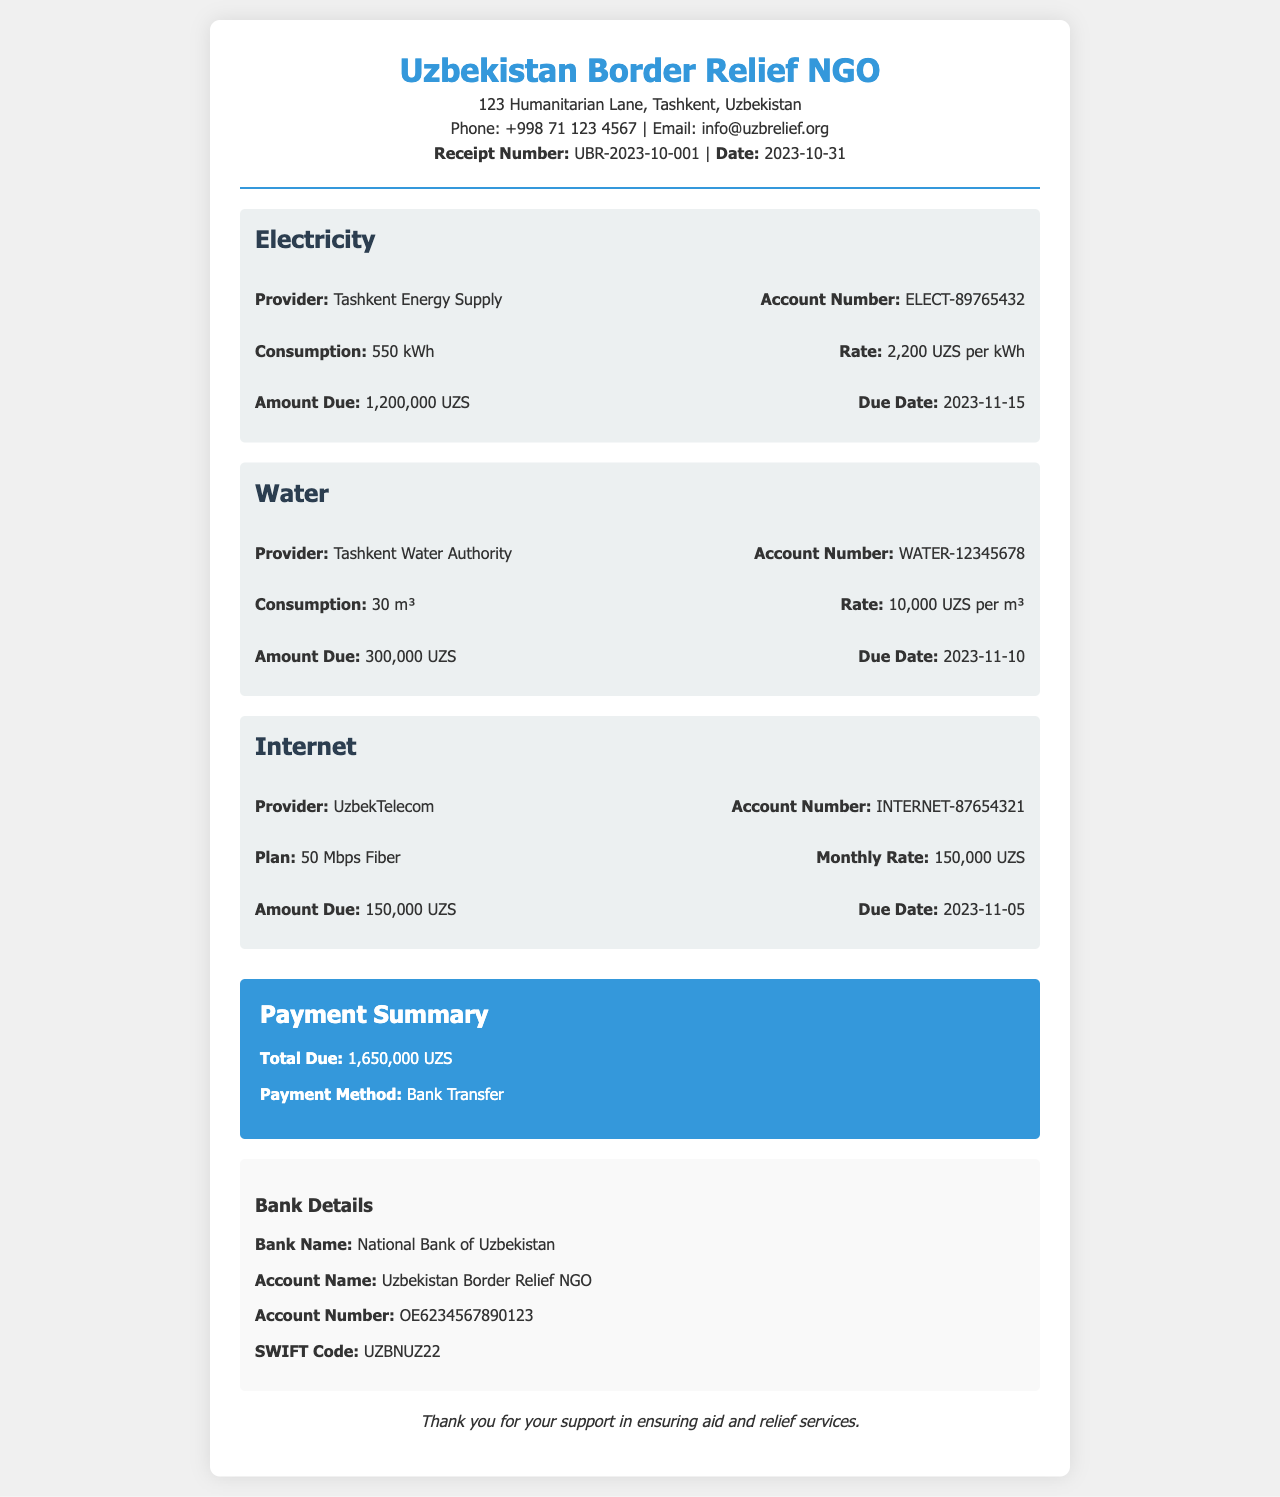what is the receipt number? The receipt number is a unique identifier for this payment transaction found in the document.
Answer: UBR-2023-10-001 what is the total due amount? The total due amount is calculated from the individual utility payments listed in the document.
Answer: 1,650,000 UZS who is the electricity provider? The document specifies the company that supplies electricity to the NGO.
Answer: Tashkent Energy Supply what is the due date for the water payment? The document indicates the deadline by which the water payment must be made.
Answer: 2023-11-10 how much was consumed for internet services? The document provides details on the specific monthly internet plan and its attributes.
Answer: 50 Mbps Fiber what is the account number for electricity? The document includes the account number needed for payment or reference for the electricity provider.
Answer: ELECT-89765432 which bank is mentioned for the payment? The document lists the bank where the payment can be made.
Answer: National Bank of Uzbekistan what is the consumption for water? The document specifies the amount of water used that reflects in the bill.
Answer: 30 m³ what is the rate per kWh for electricity? The document provides the price charged for electricity per unit consumed.
Answer: 2,200 UZS per kWh 